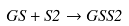<formula> <loc_0><loc_0><loc_500><loc_500>G S + S 2 \rightarrow G S S 2</formula> 